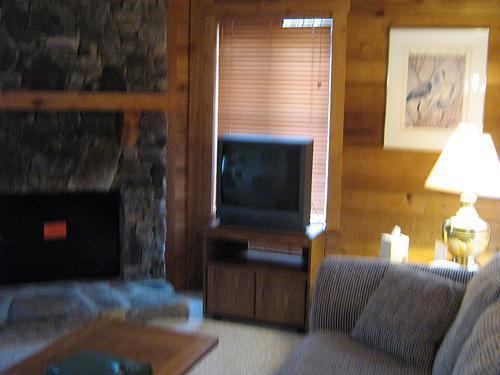How many table lamps are in the picture?
Give a very brief answer. 1. 